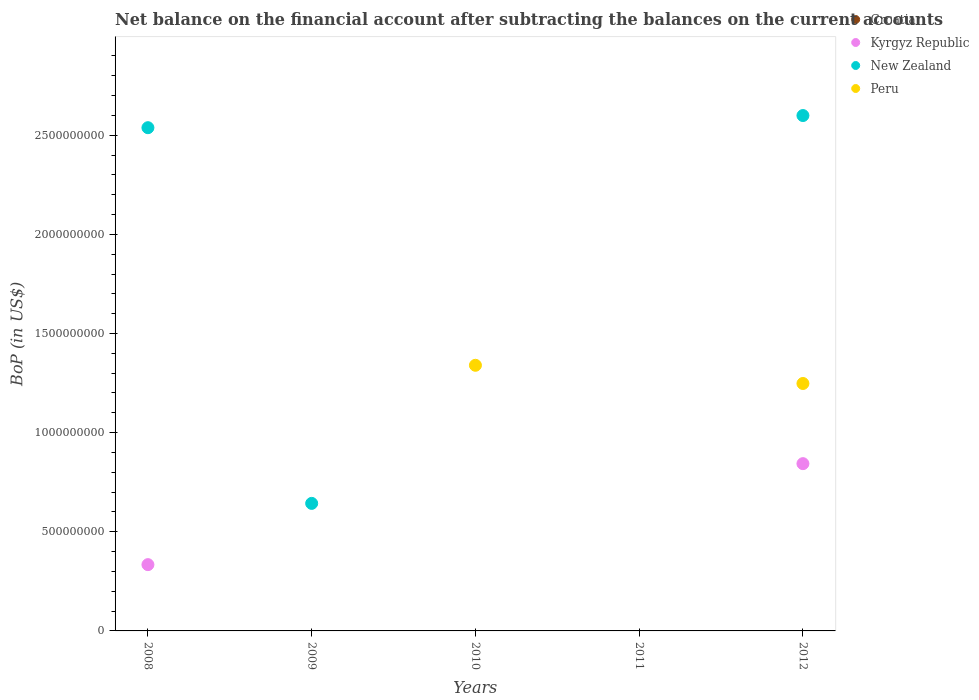How many different coloured dotlines are there?
Provide a short and direct response. 3. Is the number of dotlines equal to the number of legend labels?
Provide a short and direct response. No. What is the Balance of Payments in Kyrgyz Republic in 2012?
Offer a very short reply. 8.44e+08. Across all years, what is the maximum Balance of Payments in Peru?
Ensure brevity in your answer.  1.34e+09. Across all years, what is the minimum Balance of Payments in Peru?
Give a very brief answer. 0. What is the total Balance of Payments in Kyrgyz Republic in the graph?
Your response must be concise. 1.18e+09. What is the difference between the Balance of Payments in New Zealand in 2008 and that in 2012?
Provide a succinct answer. -6.13e+07. What is the difference between the Balance of Payments in Croatia in 2010 and the Balance of Payments in New Zealand in 2009?
Your answer should be compact. -6.43e+08. What is the average Balance of Payments in Croatia per year?
Provide a succinct answer. 0. In the year 2008, what is the difference between the Balance of Payments in New Zealand and Balance of Payments in Kyrgyz Republic?
Your response must be concise. 2.20e+09. In how many years, is the Balance of Payments in Croatia greater than 700000000 US$?
Provide a short and direct response. 0. What is the ratio of the Balance of Payments in New Zealand in 2008 to that in 2012?
Make the answer very short. 0.98. What is the difference between the highest and the second highest Balance of Payments in New Zealand?
Your response must be concise. 6.13e+07. What is the difference between the highest and the lowest Balance of Payments in Kyrgyz Republic?
Make the answer very short. 8.44e+08. In how many years, is the Balance of Payments in New Zealand greater than the average Balance of Payments in New Zealand taken over all years?
Offer a terse response. 2. How many dotlines are there?
Provide a succinct answer. 3. How many years are there in the graph?
Provide a succinct answer. 5. Are the values on the major ticks of Y-axis written in scientific E-notation?
Make the answer very short. No. Where does the legend appear in the graph?
Ensure brevity in your answer.  Top right. How many legend labels are there?
Give a very brief answer. 4. What is the title of the graph?
Offer a terse response. Net balance on the financial account after subtracting the balances on the current accounts. What is the label or title of the X-axis?
Ensure brevity in your answer.  Years. What is the label or title of the Y-axis?
Your answer should be compact. BoP (in US$). What is the BoP (in US$) of Croatia in 2008?
Provide a succinct answer. 0. What is the BoP (in US$) of Kyrgyz Republic in 2008?
Your answer should be compact. 3.34e+08. What is the BoP (in US$) of New Zealand in 2008?
Provide a short and direct response. 2.54e+09. What is the BoP (in US$) in Kyrgyz Republic in 2009?
Offer a very short reply. 0. What is the BoP (in US$) in New Zealand in 2009?
Offer a very short reply. 6.43e+08. What is the BoP (in US$) of Peru in 2009?
Ensure brevity in your answer.  0. What is the BoP (in US$) in Croatia in 2010?
Offer a terse response. 0. What is the BoP (in US$) of Kyrgyz Republic in 2010?
Your answer should be very brief. 0. What is the BoP (in US$) in Peru in 2010?
Your answer should be compact. 1.34e+09. What is the BoP (in US$) in New Zealand in 2011?
Your answer should be compact. 0. What is the BoP (in US$) of Peru in 2011?
Offer a terse response. 0. What is the BoP (in US$) in Croatia in 2012?
Your answer should be very brief. 0. What is the BoP (in US$) in Kyrgyz Republic in 2012?
Offer a terse response. 8.44e+08. What is the BoP (in US$) of New Zealand in 2012?
Make the answer very short. 2.60e+09. What is the BoP (in US$) in Peru in 2012?
Ensure brevity in your answer.  1.25e+09. Across all years, what is the maximum BoP (in US$) of Kyrgyz Republic?
Keep it short and to the point. 8.44e+08. Across all years, what is the maximum BoP (in US$) of New Zealand?
Your response must be concise. 2.60e+09. Across all years, what is the maximum BoP (in US$) of Peru?
Your answer should be compact. 1.34e+09. Across all years, what is the minimum BoP (in US$) of Kyrgyz Republic?
Ensure brevity in your answer.  0. What is the total BoP (in US$) in Croatia in the graph?
Your response must be concise. 0. What is the total BoP (in US$) in Kyrgyz Republic in the graph?
Your answer should be compact. 1.18e+09. What is the total BoP (in US$) in New Zealand in the graph?
Ensure brevity in your answer.  5.78e+09. What is the total BoP (in US$) in Peru in the graph?
Keep it short and to the point. 2.59e+09. What is the difference between the BoP (in US$) of New Zealand in 2008 and that in 2009?
Your answer should be compact. 1.89e+09. What is the difference between the BoP (in US$) of Kyrgyz Republic in 2008 and that in 2012?
Keep it short and to the point. -5.09e+08. What is the difference between the BoP (in US$) in New Zealand in 2008 and that in 2012?
Your answer should be compact. -6.13e+07. What is the difference between the BoP (in US$) in New Zealand in 2009 and that in 2012?
Offer a very short reply. -1.96e+09. What is the difference between the BoP (in US$) in Peru in 2010 and that in 2012?
Provide a short and direct response. 9.18e+07. What is the difference between the BoP (in US$) of Kyrgyz Republic in 2008 and the BoP (in US$) of New Zealand in 2009?
Offer a very short reply. -3.09e+08. What is the difference between the BoP (in US$) of Kyrgyz Republic in 2008 and the BoP (in US$) of Peru in 2010?
Provide a short and direct response. -1.01e+09. What is the difference between the BoP (in US$) in New Zealand in 2008 and the BoP (in US$) in Peru in 2010?
Your answer should be compact. 1.20e+09. What is the difference between the BoP (in US$) of Kyrgyz Republic in 2008 and the BoP (in US$) of New Zealand in 2012?
Offer a terse response. -2.26e+09. What is the difference between the BoP (in US$) of Kyrgyz Republic in 2008 and the BoP (in US$) of Peru in 2012?
Offer a very short reply. -9.14e+08. What is the difference between the BoP (in US$) in New Zealand in 2008 and the BoP (in US$) in Peru in 2012?
Offer a very short reply. 1.29e+09. What is the difference between the BoP (in US$) in New Zealand in 2009 and the BoP (in US$) in Peru in 2010?
Make the answer very short. -6.96e+08. What is the difference between the BoP (in US$) in New Zealand in 2009 and the BoP (in US$) in Peru in 2012?
Make the answer very short. -6.05e+08. What is the average BoP (in US$) of Croatia per year?
Ensure brevity in your answer.  0. What is the average BoP (in US$) of Kyrgyz Republic per year?
Provide a succinct answer. 2.36e+08. What is the average BoP (in US$) of New Zealand per year?
Provide a short and direct response. 1.16e+09. What is the average BoP (in US$) in Peru per year?
Keep it short and to the point. 5.18e+08. In the year 2008, what is the difference between the BoP (in US$) of Kyrgyz Republic and BoP (in US$) of New Zealand?
Make the answer very short. -2.20e+09. In the year 2012, what is the difference between the BoP (in US$) of Kyrgyz Republic and BoP (in US$) of New Zealand?
Provide a short and direct response. -1.76e+09. In the year 2012, what is the difference between the BoP (in US$) of Kyrgyz Republic and BoP (in US$) of Peru?
Your answer should be compact. -4.04e+08. In the year 2012, what is the difference between the BoP (in US$) of New Zealand and BoP (in US$) of Peru?
Offer a very short reply. 1.35e+09. What is the ratio of the BoP (in US$) in New Zealand in 2008 to that in 2009?
Provide a succinct answer. 3.95. What is the ratio of the BoP (in US$) of Kyrgyz Republic in 2008 to that in 2012?
Offer a very short reply. 0.4. What is the ratio of the BoP (in US$) in New Zealand in 2008 to that in 2012?
Your answer should be compact. 0.98. What is the ratio of the BoP (in US$) of New Zealand in 2009 to that in 2012?
Provide a succinct answer. 0.25. What is the ratio of the BoP (in US$) of Peru in 2010 to that in 2012?
Ensure brevity in your answer.  1.07. What is the difference between the highest and the second highest BoP (in US$) in New Zealand?
Your answer should be very brief. 6.13e+07. What is the difference between the highest and the lowest BoP (in US$) of Kyrgyz Republic?
Provide a succinct answer. 8.44e+08. What is the difference between the highest and the lowest BoP (in US$) of New Zealand?
Your answer should be very brief. 2.60e+09. What is the difference between the highest and the lowest BoP (in US$) of Peru?
Your response must be concise. 1.34e+09. 